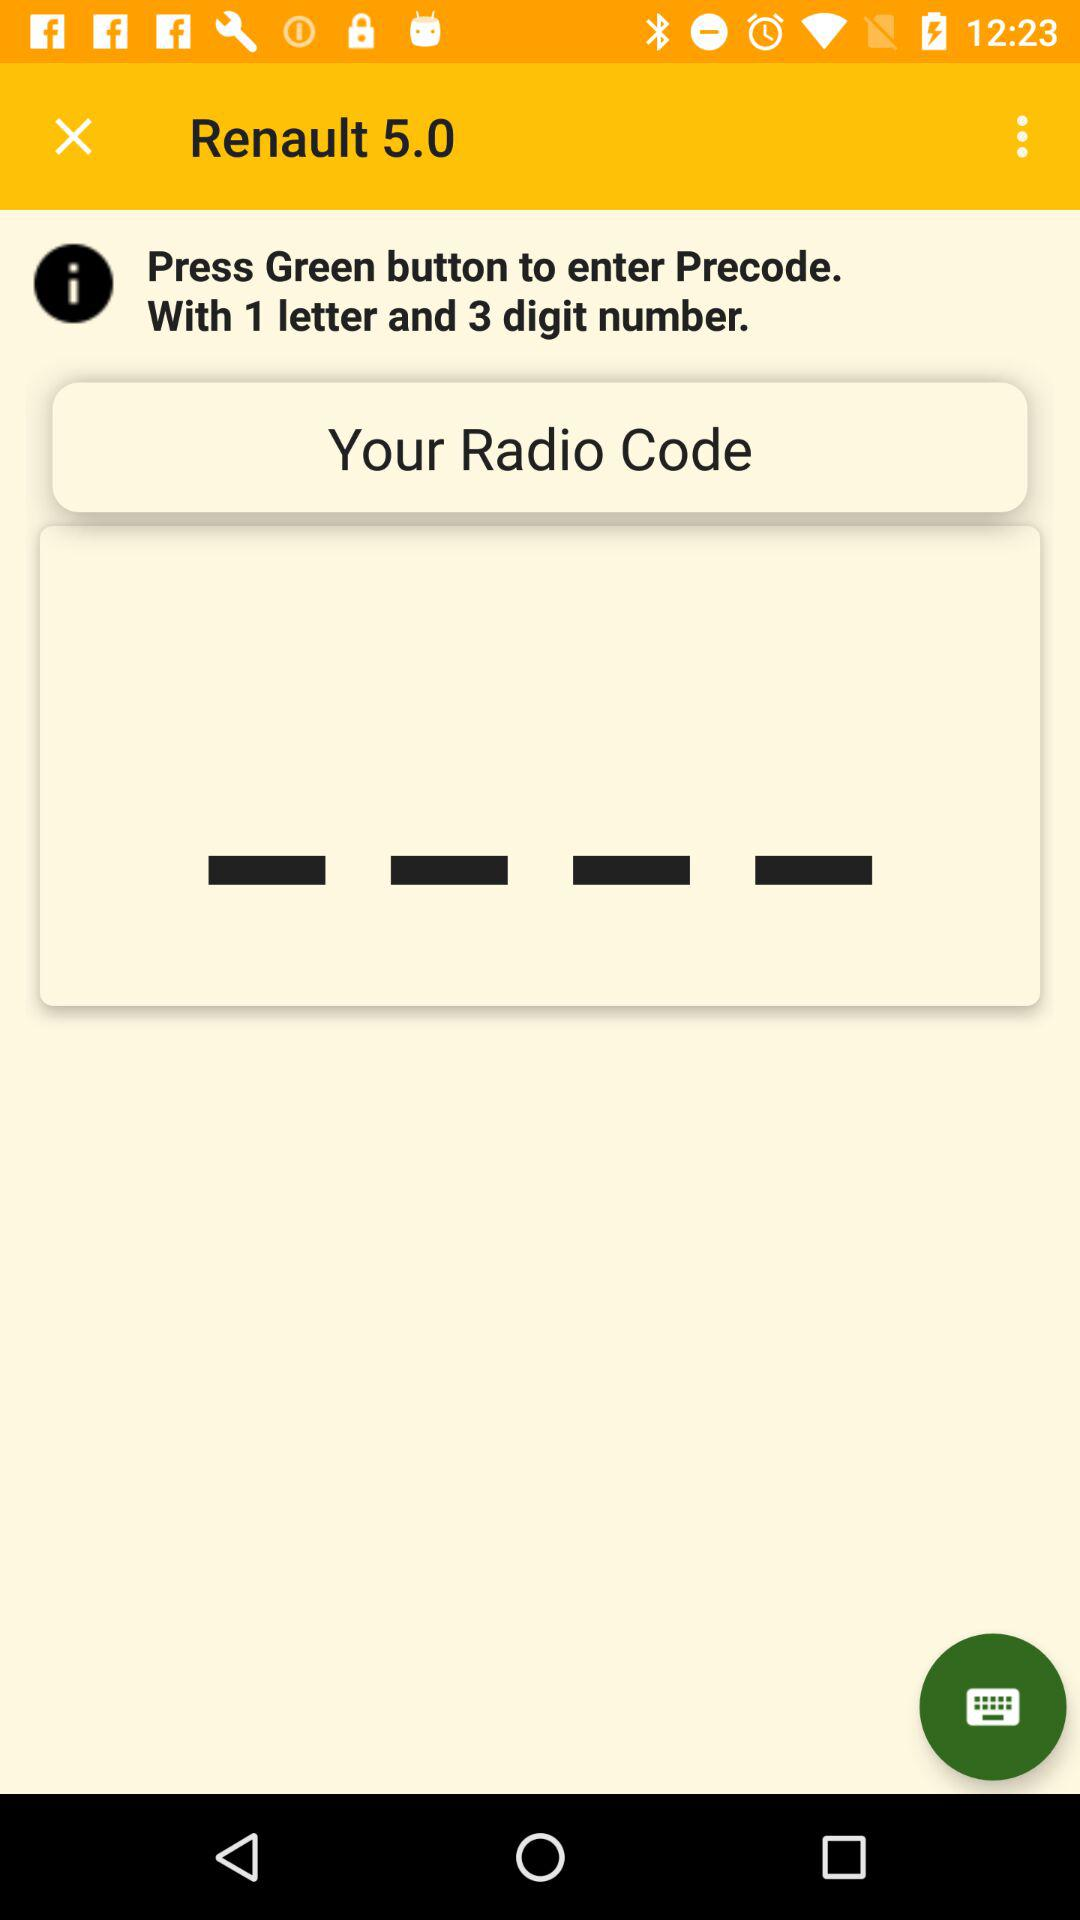Which button we press to enter the precode? You have to press the green button. 